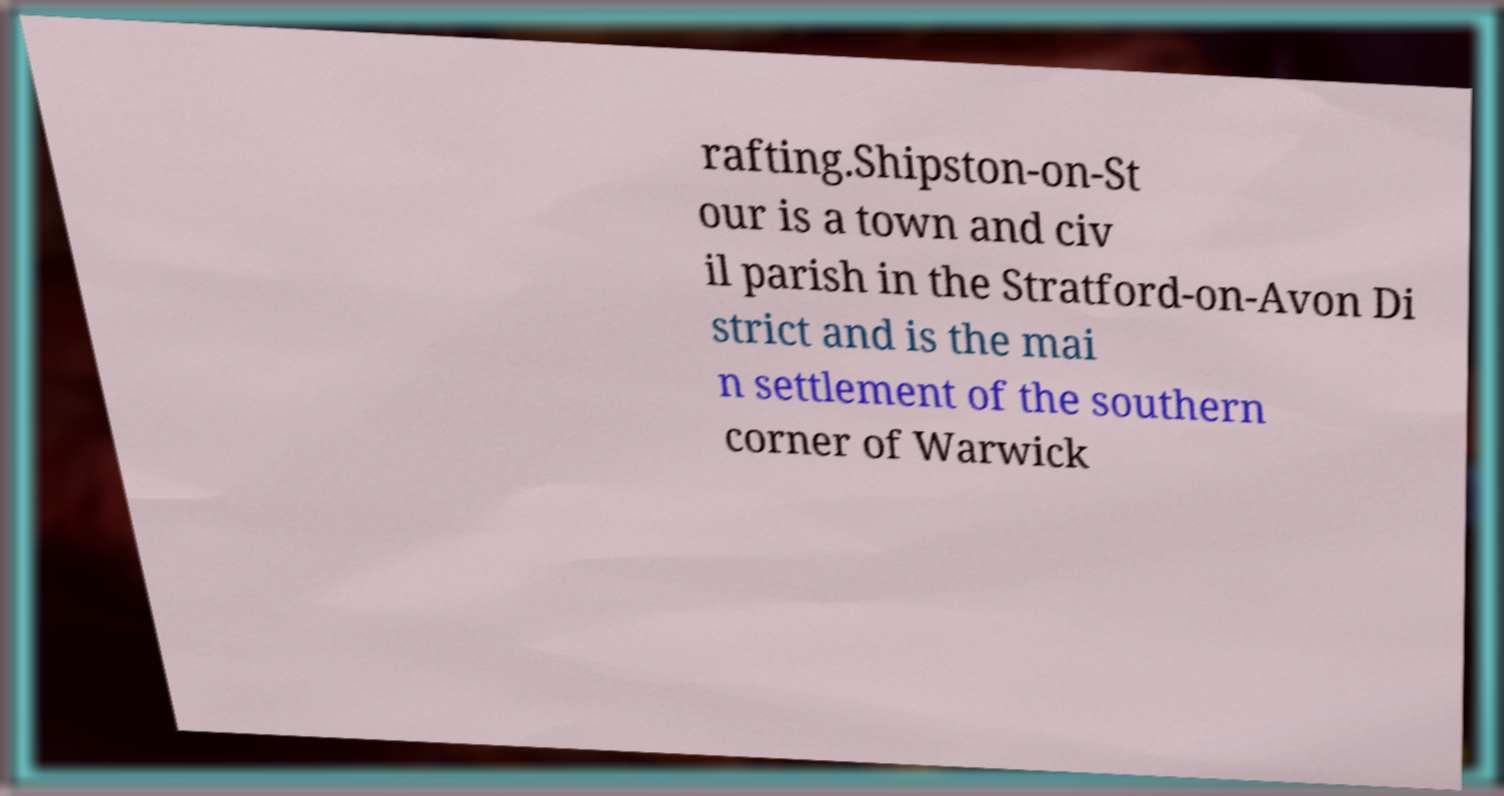Please identify and transcribe the text found in this image. rafting.Shipston-on-St our is a town and civ il parish in the Stratford-on-Avon Di strict and is the mai n settlement of the southern corner of Warwick 